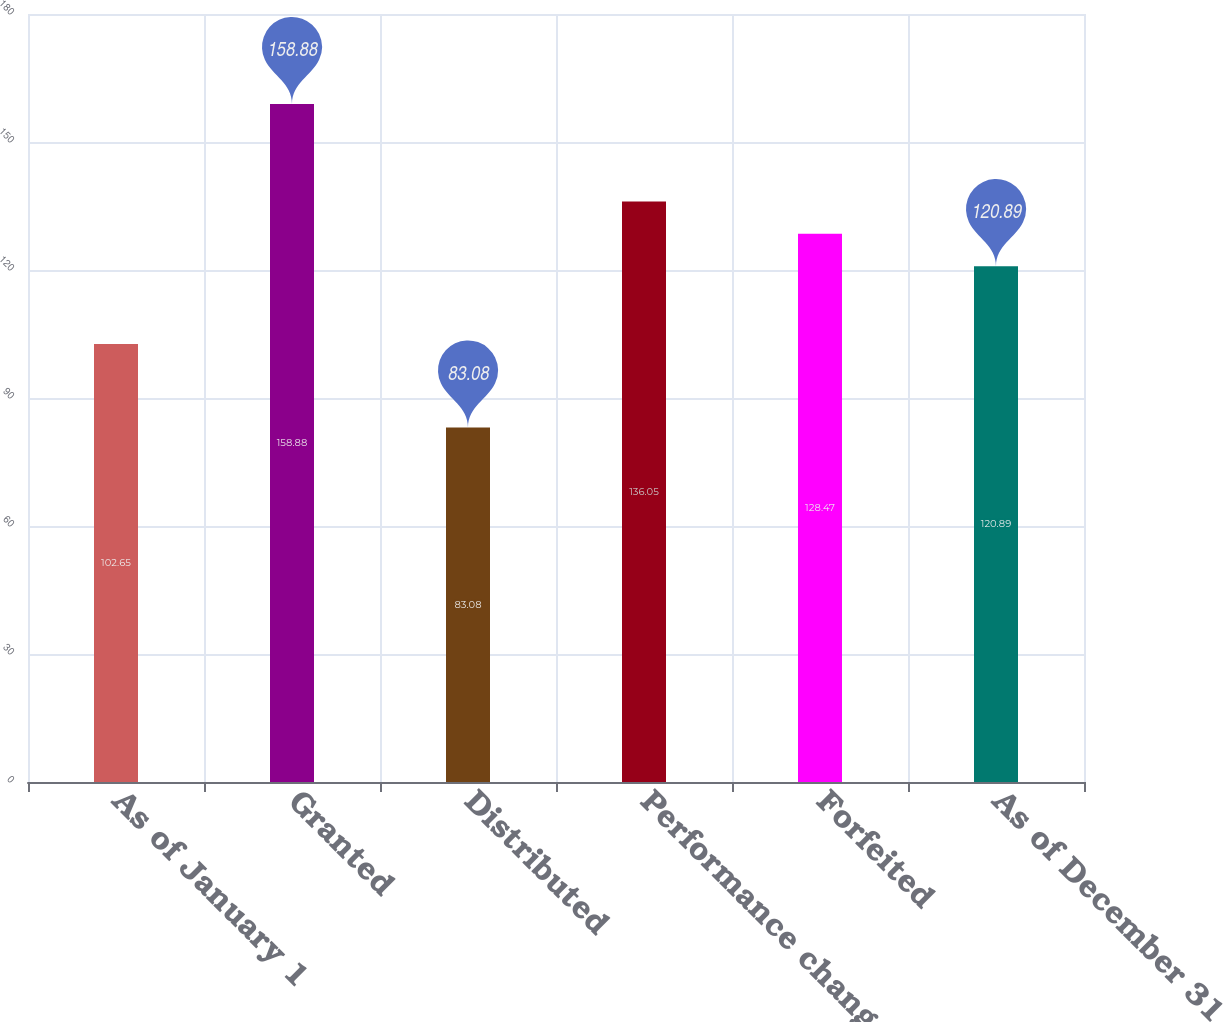Convert chart to OTSL. <chart><loc_0><loc_0><loc_500><loc_500><bar_chart><fcel>As of January 1<fcel>Granted<fcel>Distributed<fcel>Performance change<fcel>Forfeited<fcel>As of December 31<nl><fcel>102.65<fcel>158.88<fcel>83.08<fcel>136.05<fcel>128.47<fcel>120.89<nl></chart> 